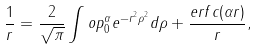Convert formula to latex. <formula><loc_0><loc_0><loc_500><loc_500>\frac { 1 } { r } = \frac { 2 } { \sqrt { \pi } } \int o p _ { 0 } ^ { \alpha } e ^ { - r ^ { 2 } \rho ^ { 2 } } d \rho + \frac { e r f c ( \alpha r ) } { r } ,</formula> 